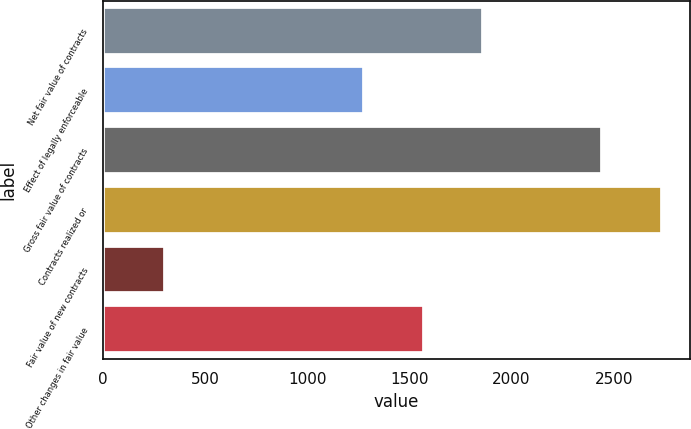Convert chart to OTSL. <chart><loc_0><loc_0><loc_500><loc_500><bar_chart><fcel>Net fair value of contracts<fcel>Effect of legally enforceable<fcel>Gross fair value of contracts<fcel>Contracts realized or<fcel>Fair value of new contracts<fcel>Other changes in fair value<nl><fcel>1861.8<fcel>1279<fcel>2444.6<fcel>2736<fcel>303<fcel>1570.4<nl></chart> 